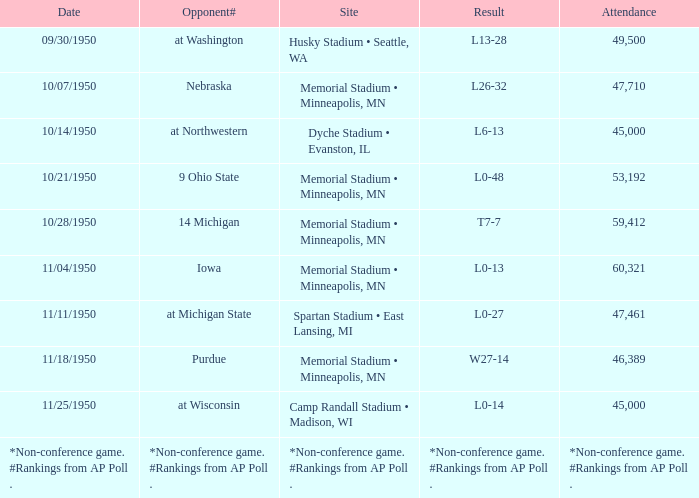What is the date when the conclusion is *non-conference game. #rankings from ap poll .? *Non-conference game. #Rankings from AP Poll . Would you be able to parse every entry in this table? {'header': ['Date', 'Opponent#', 'Site', 'Result', 'Attendance'], 'rows': [['09/30/1950', 'at Washington', 'Husky Stadium • Seattle, WA', 'L13-28', '49,500'], ['10/07/1950', 'Nebraska', 'Memorial Stadium • Minneapolis, MN', 'L26-32', '47,710'], ['10/14/1950', 'at Northwestern', 'Dyche Stadium • Evanston, IL', 'L6-13', '45,000'], ['10/21/1950', '9 Ohio State', 'Memorial Stadium • Minneapolis, MN', 'L0-48', '53,192'], ['10/28/1950', '14 Michigan', 'Memorial Stadium • Minneapolis, MN', 'T7-7', '59,412'], ['11/04/1950', 'Iowa', 'Memorial Stadium • Minneapolis, MN', 'L0-13', '60,321'], ['11/11/1950', 'at Michigan State', 'Spartan Stadium • East Lansing, MI', 'L0-27', '47,461'], ['11/18/1950', 'Purdue', 'Memorial Stadium • Minneapolis, MN', 'W27-14', '46,389'], ['11/25/1950', 'at Wisconsin', 'Camp Randall Stadium • Madison, WI', 'L0-14', '45,000'], ['*Non-conference game. #Rankings from AP Poll .', '*Non-conference game. #Rankings from AP Poll .', '*Non-conference game. #Rankings from AP Poll .', '*Non-conference game. #Rankings from AP Poll .', '*Non-conference game. #Rankings from AP Poll .']]} 